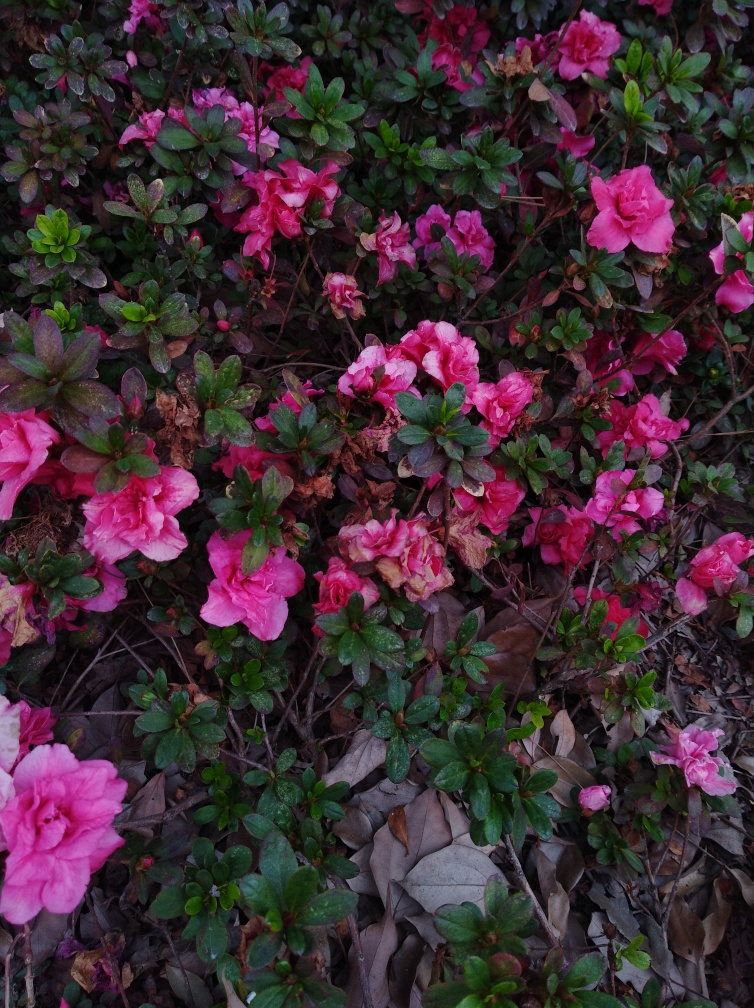What type of flowers are these? These flowers appear to be azaleas, which are known for their vibrant colors and are a popular choice for gardens and ornamental plantings. Are azaleas difficult to maintain? Azaleas require some care to thrive, including well-drained acidic soil, partial shade, and regular watering. They also benefit from fertilization and pruning to encourage healthy growth and flowering. 